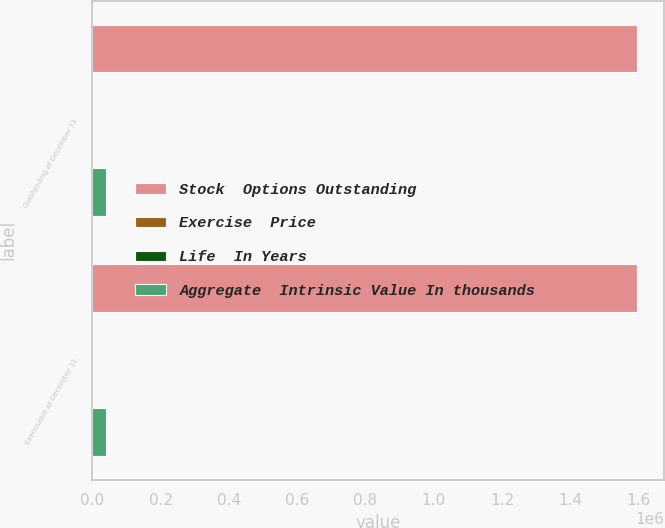Convert chart to OTSL. <chart><loc_0><loc_0><loc_500><loc_500><stacked_bar_chart><ecel><fcel>Outstanding at December 31<fcel>Exercisable at December 31<nl><fcel>Stock  Options Outstanding<fcel>1.59459e+06<fcel>1.59415e+06<nl><fcel>Exercise  Price<fcel>139.6<fcel>139.6<nl><fcel>Life  In Years<fcel>1.5<fcel>1.5<nl><fcel>Aggregate  Intrinsic Value In thousands<fcel>39326<fcel>39305<nl></chart> 